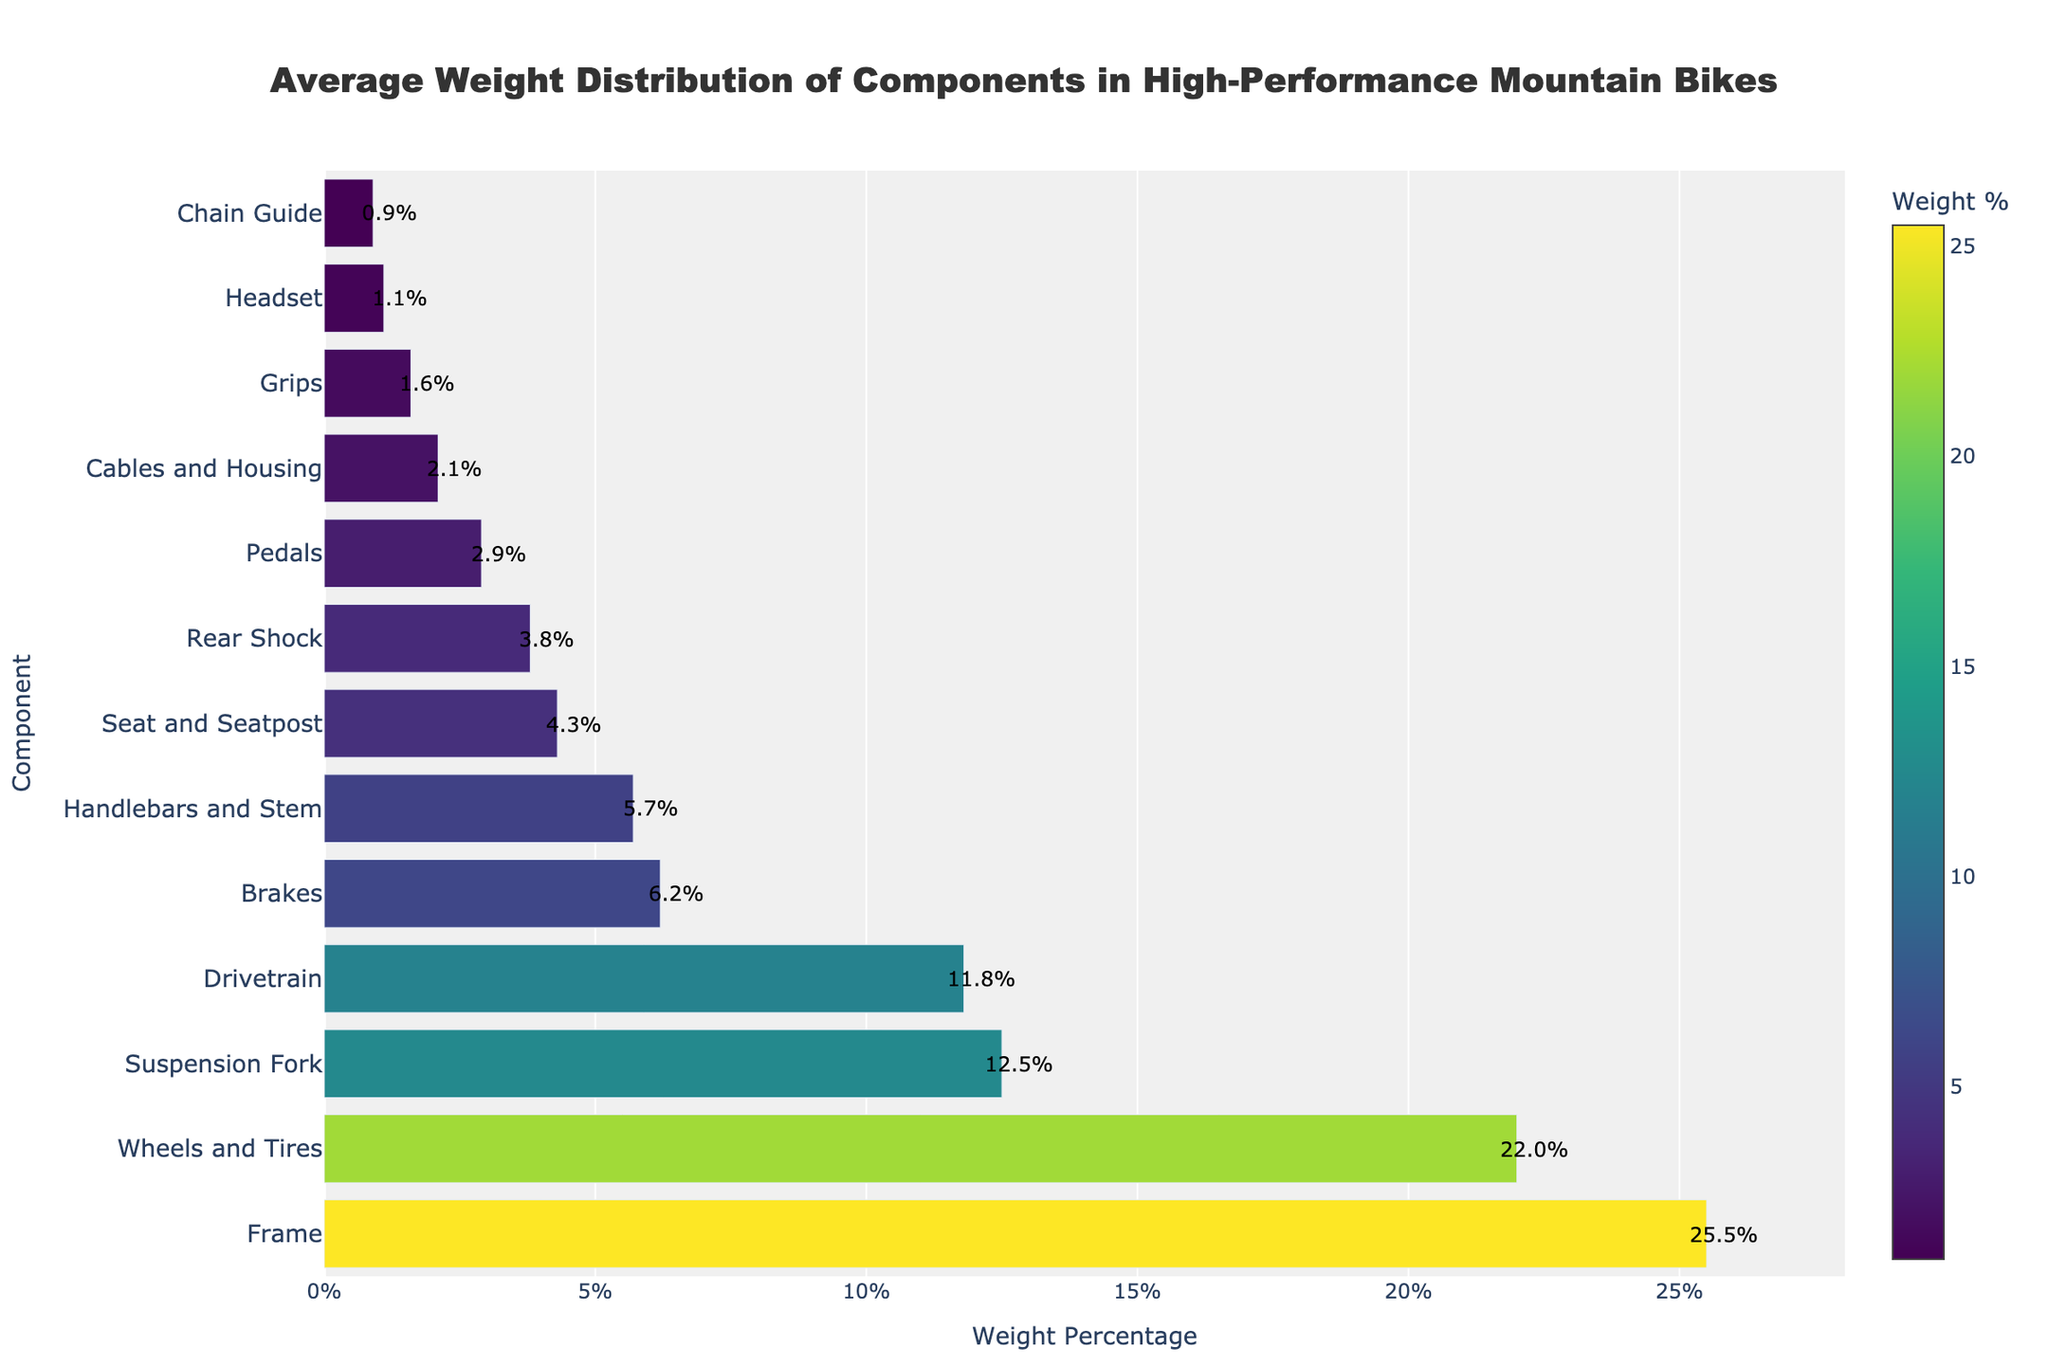What's the component with the highest weight percentage? Locate the bar with the longest length or highest value on the x-axis. The 'Frame' component has the longest bar with a weight percentage of 25.5%.
Answer: Frame Which components have a weight percentage higher than 20%? Identify bars with values on the x-axis exceeding 20%. The components 'Frame' and 'Wheels and Tires' satisfy this condition.
Answer: Frame, Wheels and Tires What's the combined weight percentage of the Drivetrain and Brakes components? Locate the 'Drivetrain' and 'Brakes' bars, then sum their weight percentages (11.8 + 6.2).
Answer: 18.0% How does the weight percentage of the Suspension Fork compare to the Rear Shock? Observe and compare the lengths of the 'Suspension Fork' and 'Rear Shock' bars. The 'Suspension Fork' has a weight percentage of 12.5%, which is greater than the 'Rear Shock' with 3.8%.
Answer: Suspension Fork is greater Which component has the lowest weight percentage? Locate the bar with the shortest length or smallest value on the x-axis. The 'Chain Guide' has the smallest weight percentage of 0.9%.
Answer: Chain Guide What's the difference in weight percentage between the Seat and Seatpost, and the Pedals? Locate the bars for 'Seat and Seatpost' (4.3%) and 'Pedals' (2.9%), then find the difference (4.3 - 2.9).
Answer: 1.4% List the components with a weight percentage less than 5%. Identify bars with values on the x-axis below 5%. The components 'Seat and Seatpost', 'Rear Shock', 'Pedals', 'Cables and Housing', 'Grips', 'Headset', and 'Chain Guide' meet this condition.
Answer: Seat and Seatpost, Rear Shock, Pedals, Cables and Housing, Grips, Headset, Chain Guide What is the average weight percentage of the components 'Handlebars and Stem', 'Grips', and 'Headset'? Identify the weight percentages (5.7, 1.6, and 1.1), sum them (5.7 + 1.6 + 1.1 = 8.4), and divide by the number of components (8.4 / 3).
Answer: 2.8% What's the ratio of the weight percentage of Wheels and Tires to the Drivetrain? Locate the weight percentages (22.0 for Wheels and Tires, 11.8 for Drivetrain), then divide them (22.0 / 11.8).
Answer: 1.86 What's the second heaviest component after the Frame? The bar with the next longest length after 'Frame' is 'Wheels and Tires', with a weight percentage of 22.0%.
Answer: Wheels and Tires 